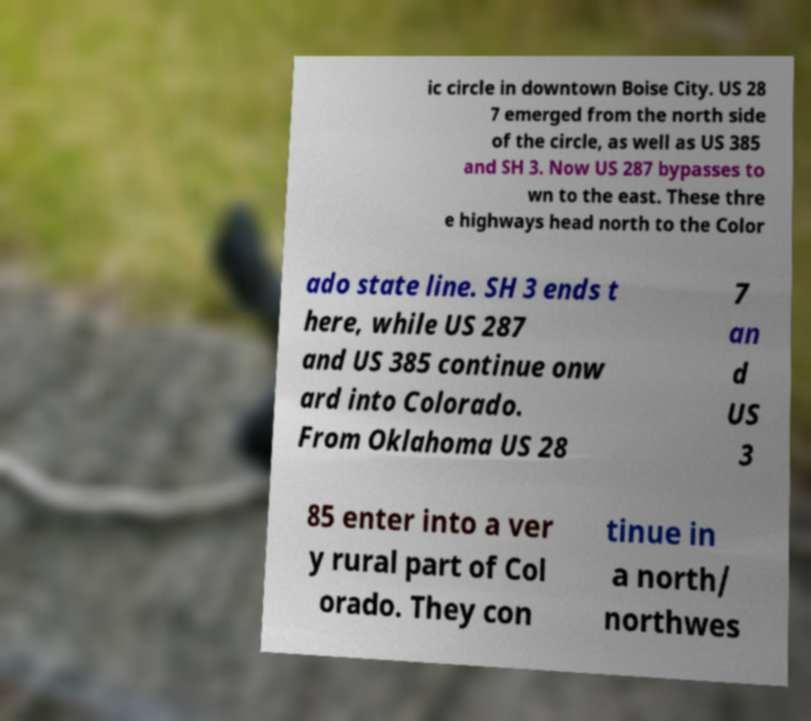Please read and relay the text visible in this image. What does it say? ic circle in downtown Boise City. US 28 7 emerged from the north side of the circle, as well as US 385 and SH 3. Now US 287 bypasses to wn to the east. These thre e highways head north to the Color ado state line. SH 3 ends t here, while US 287 and US 385 continue onw ard into Colorado. From Oklahoma US 28 7 an d US 3 85 enter into a ver y rural part of Col orado. They con tinue in a north/ northwes 